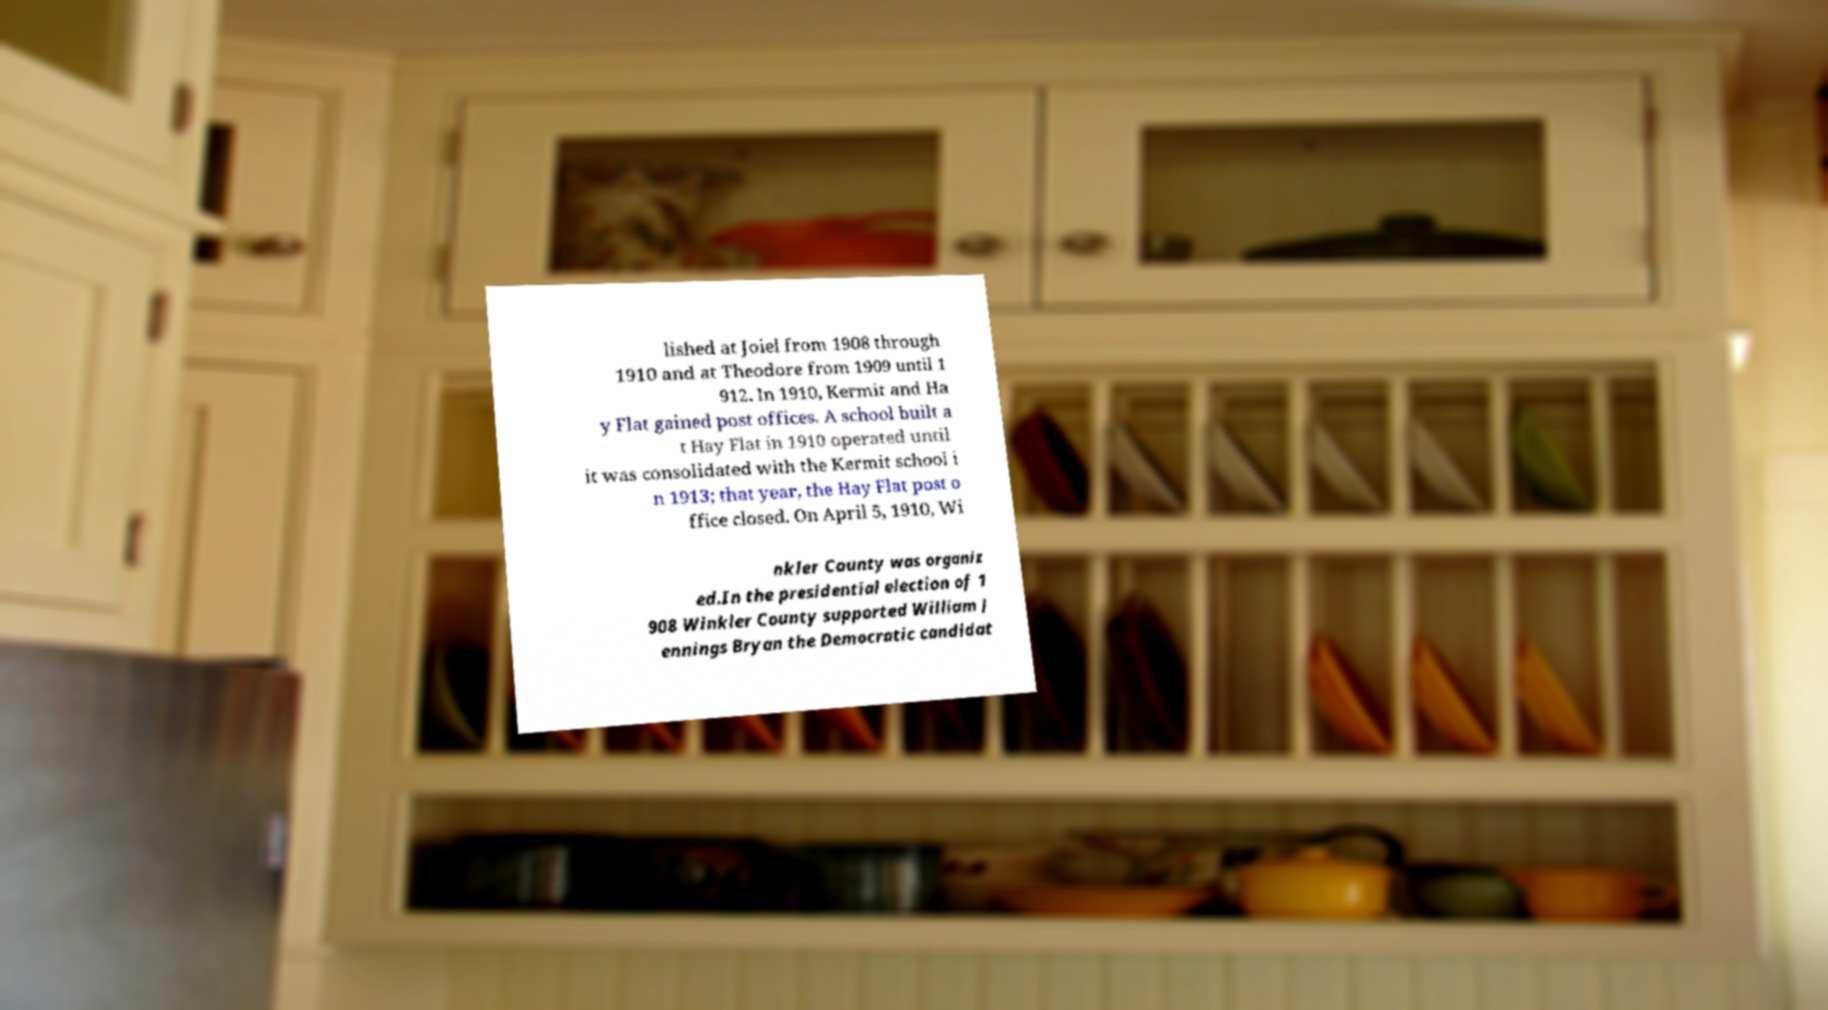I need the written content from this picture converted into text. Can you do that? lished at Joiel from 1908 through 1910 and at Theodore from 1909 until 1 912. In 1910, Kermit and Ha y Flat gained post offices. A school built a t Hay Flat in 1910 operated until it was consolidated with the Kermit school i n 1913; that year, the Hay Flat post o ffice closed. On April 5, 1910, Wi nkler County was organiz ed.In the presidential election of 1 908 Winkler County supported William J ennings Bryan the Democratic candidat 